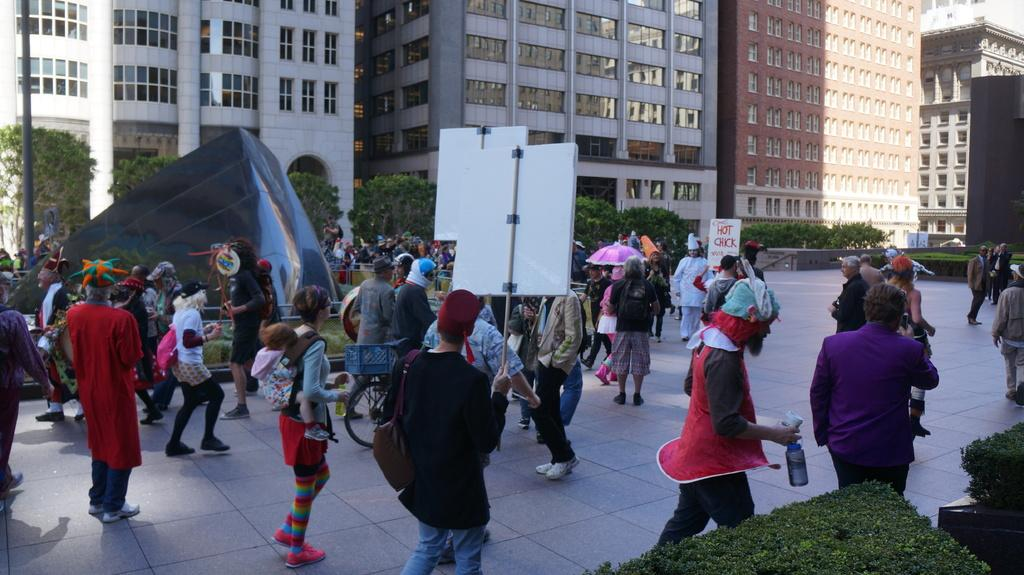How many people can be seen in the image? There are people in the image, but the exact number is not specified. What are some people doing in the image? Some people are holding placards in the image. What mode of transportation is present in the image? Bicycles are present in the image. What can be seen in the background of the image? There are trees, plants, a pole, and buildings visible in the background of the image. How many clover leaves are visible on the placards in the image? There is no mention of clover leaves on the placards in the image, so it is not possible to determine their presence or quantity. What type of slavery is being protested in the image? There is no indication of a protest or slavery in the image, so it is not possible to determine the type of slavery being protested. 